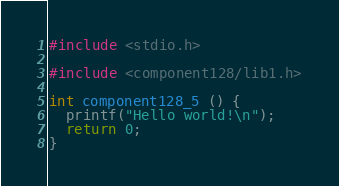<code> <loc_0><loc_0><loc_500><loc_500><_C++_>#include <stdio.h>

#include <component128/lib1.h>

int component128_5 () {
  printf("Hello world!\n");
  return 0;
}
</code> 